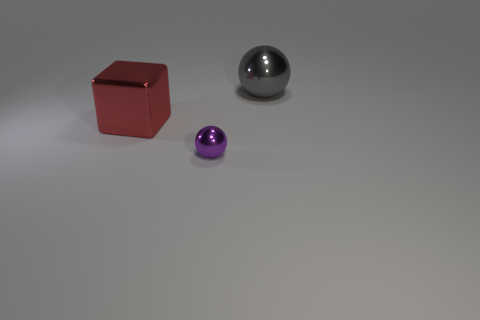Do the tiny shiny thing and the big red shiny thing have the same shape?
Provide a short and direct response. No. Is there anything else that has the same size as the red metallic thing?
Keep it short and to the point. Yes. There is another gray object that is the same shape as the small object; what is its size?
Make the answer very short. Large. Is the number of gray shiny balls that are to the left of the large gray metallic object greater than the number of small purple metal balls right of the tiny sphere?
Offer a terse response. No. Is the material of the small purple ball the same as the large object that is to the left of the gray ball?
Make the answer very short. Yes. Is there anything else that is the same shape as the small purple metallic object?
Your response must be concise. Yes. There is a object that is behind the purple thing and to the left of the big metal ball; what is its color?
Provide a short and direct response. Red. What shape is the large object that is to the left of the tiny object?
Ensure brevity in your answer.  Cube. How big is the metallic ball on the left side of the ball behind the large thing that is in front of the big gray metal sphere?
Your answer should be very brief. Small. How many large metal blocks are in front of the purple sphere on the right side of the red cube?
Keep it short and to the point. 0. 